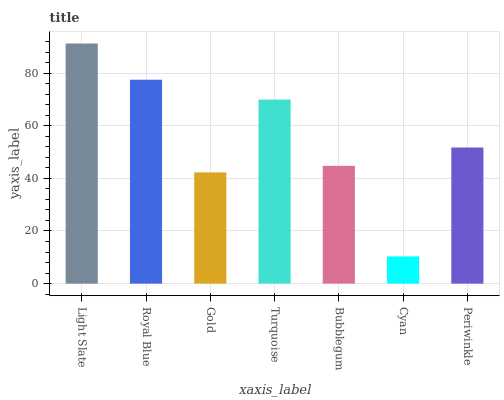Is Cyan the minimum?
Answer yes or no. Yes. Is Light Slate the maximum?
Answer yes or no. Yes. Is Royal Blue the minimum?
Answer yes or no. No. Is Royal Blue the maximum?
Answer yes or no. No. Is Light Slate greater than Royal Blue?
Answer yes or no. Yes. Is Royal Blue less than Light Slate?
Answer yes or no. Yes. Is Royal Blue greater than Light Slate?
Answer yes or no. No. Is Light Slate less than Royal Blue?
Answer yes or no. No. Is Periwinkle the high median?
Answer yes or no. Yes. Is Periwinkle the low median?
Answer yes or no. Yes. Is Light Slate the high median?
Answer yes or no. No. Is Royal Blue the low median?
Answer yes or no. No. 